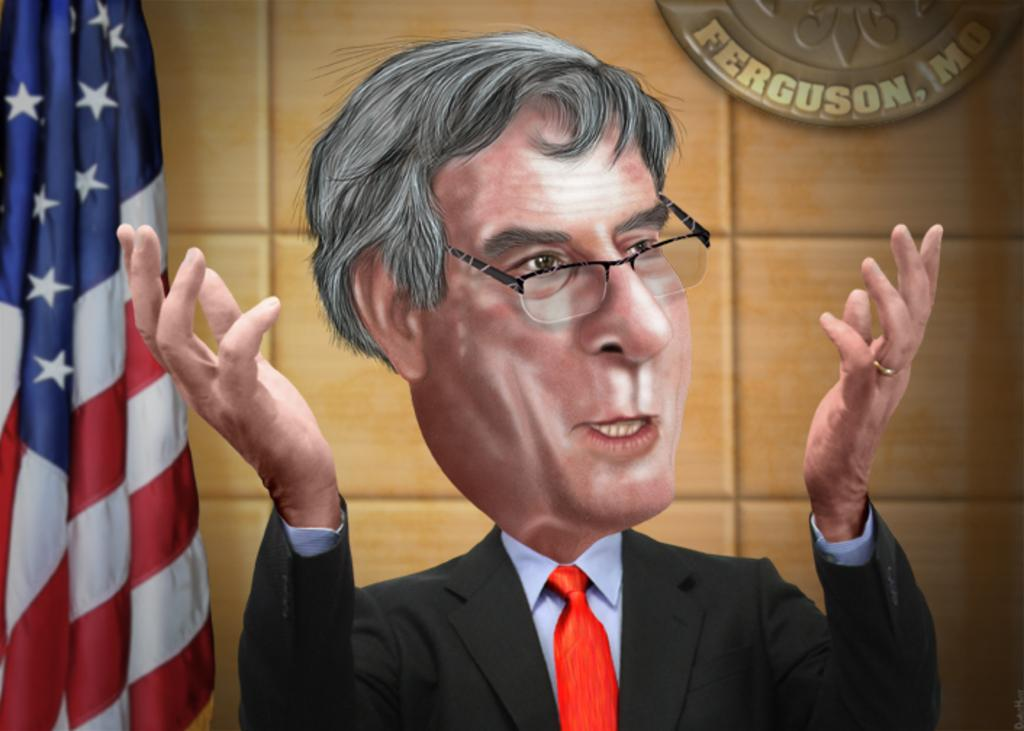What type of image is being described? The image is animated. Can you describe the person in the image? There is a person in the image wearing a coat. Where is the flag located in the image? The flag is on the left side of the image. What can be seen in the background of the image? There is a hoarding on a wall in the background of the image. What type of string is being used by the person in the image? There is no string present in the image. Can you describe the rake that the person in the image is using? There is no rake present in the image. 